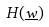<formula> <loc_0><loc_0><loc_500><loc_500>H ( \underline { w } )</formula> 